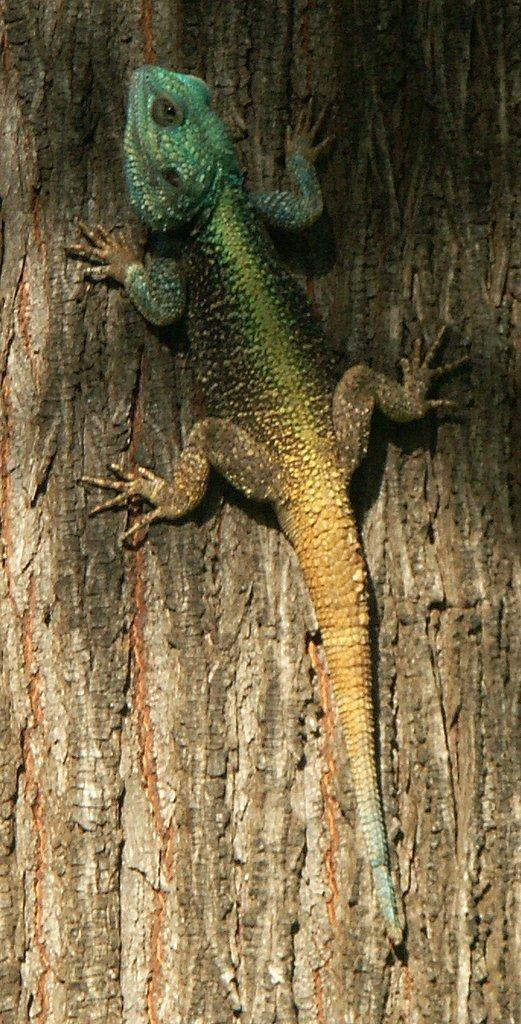What type of animal is in the image? There is a lizard in the image. Where is the lizard located? The lizard is on a tree trunk. Reasoning: Let's think step by identifying the main subject in the image, which is the lizard. Then, we describe its location, which is on a tree trunk. We formulate questions that focus on the subject and its location, ensuring that each question can be answered definitively be answered definitively with the information given. We avoid yes/no questions and ensure that the language is simple and clear. Absurd Question/Answer: What type of debt does the lizard owe to the sock in the image? There is no sock or debt present in the image; it only features a lizard on a tree trunk. What type of relation does the lizard have with the sock in the image? There is no sock present in the image; it only features a lizard on a tree trunk. The image does not provide any information about the lizard's relations with any other objects or entities. 